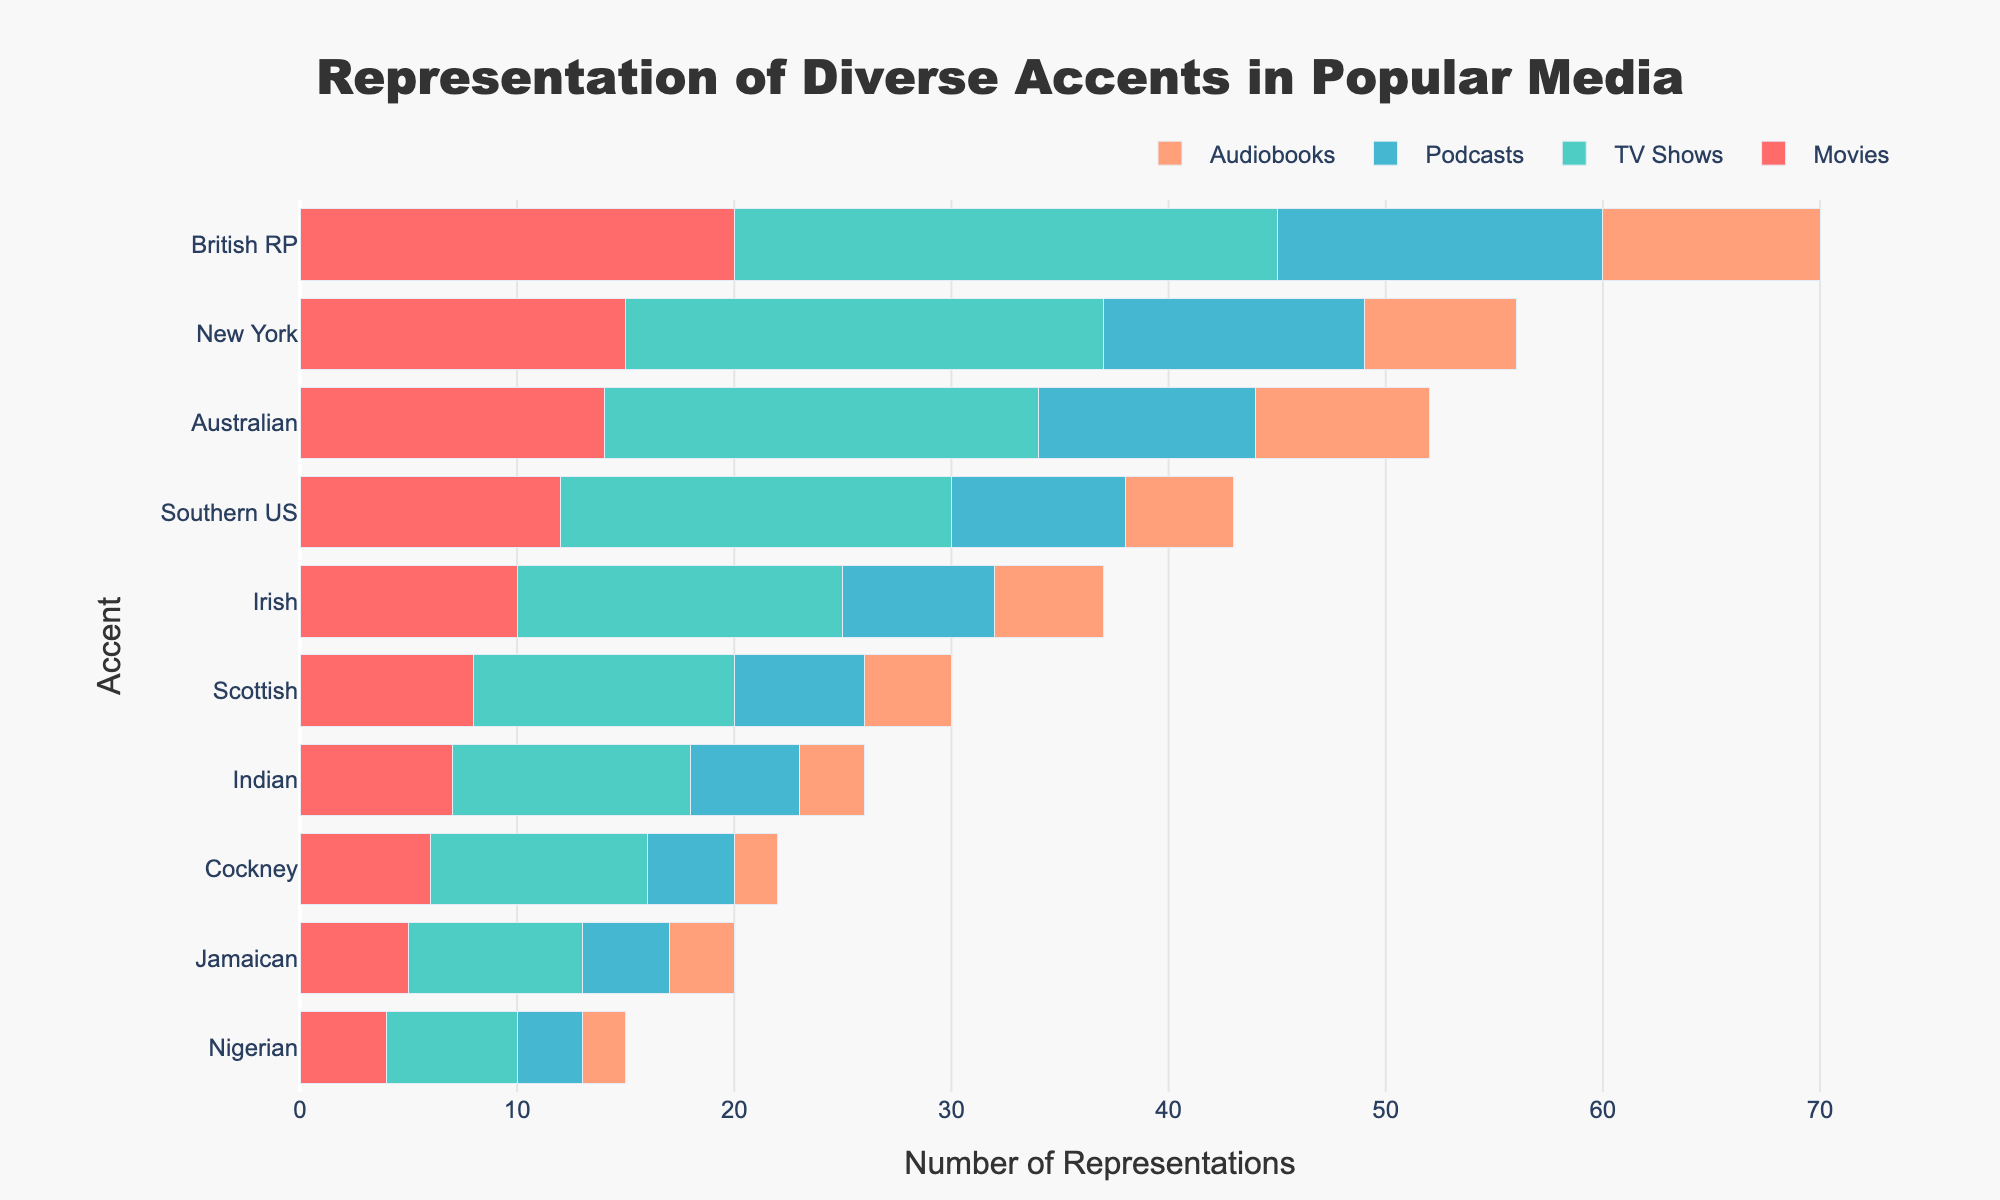What is the title of the figure? The title is typically placed at the top-center of the plot and provides a summary of the figure's contents.
Answer: Representation of Diverse Accents in Popular Media Which accent has the highest representation across all media types? By summing up the counts of all media types in the figure, we can identify the accent with the highest total representation.
Answer: British RP How many total representations do Southern US accents have across all media types? By summing the individual counts for Southern US accents in Movies, TV Shows, Podcasts, and Audiobooks, we get 12 + 18 + 8 + 5.
Answer: 43 Which accent has more representations in TV Shows: Cockney or Scottish? By comparing the counts of TV Shows for both Cockney (10) and Scottish (12), we can see which one is higher.
Answer: Scottish What is the combined total of Irish accents in Movies and Podcasts? Adding the counts for Irish accents in Movies (10) and Podcasts (7) gives us the answer.
Answer: 17 How many accents have more than 20 representations in TV Shows? By observing the bar representing TV Shows, we count how many accents exceed the 20 mark: British RP, Australian, and New York.
Answer: 3 Which media type has the least representation of Nigerian accents? By comparing the individual counts for Nigerian accents across all media types, the one with the smallest number is identified as Audiobooks (2).
Answer: Audiobooks What is the total number of representations for the New York accent in TV Shows and Podcasts combined? Adding the counts for New York accents in TV Shows (22) and Podcasts (12) gives us the answer.
Answer: 34 How do the representations of Jamaican accents in Audiobooks compare to those in Movies? By comparing the counts of Jamaican accents in Audiobooks (3) and Movies (5), we see that Movies have more.
Answer: Movies Which accent has approximately equal representations in Movies and TV Shows? By comparing the counts of representations across all accents between Movies and TV Shows, the Australian accent has 14 in Movies and 20 in TV Shows, which are relatively close.
Answer: Australian 